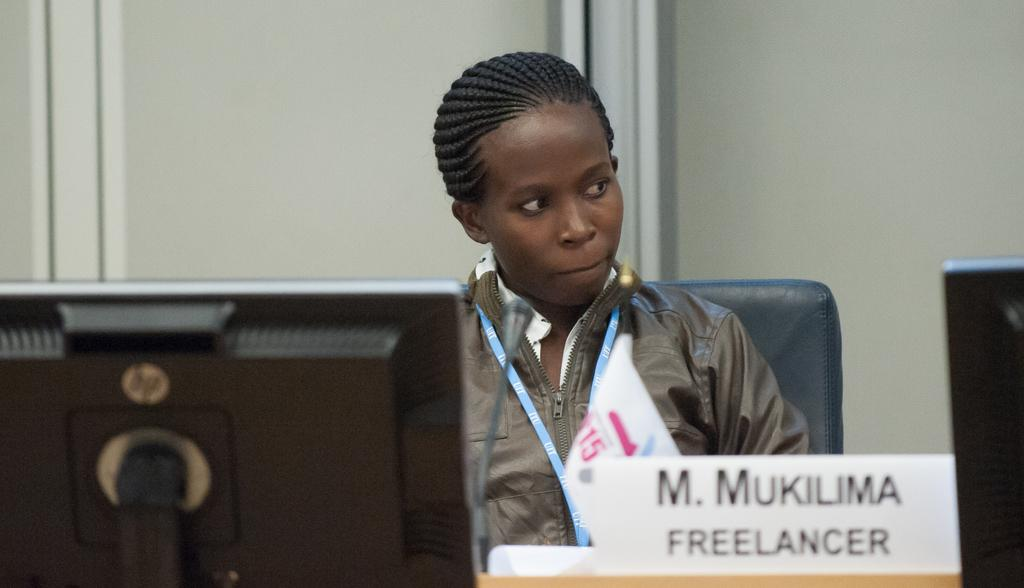What is the woman doing in the image? The woman is sitting on a chair in the image. What object is on the table in the image? There is a name board on a table in the image. What electronic device is visible in the image? There is a laptop in the image. How many centimeters long is the pencil on the table in the image? There is no pencil present in the image, so it is not possible to determine its length. 